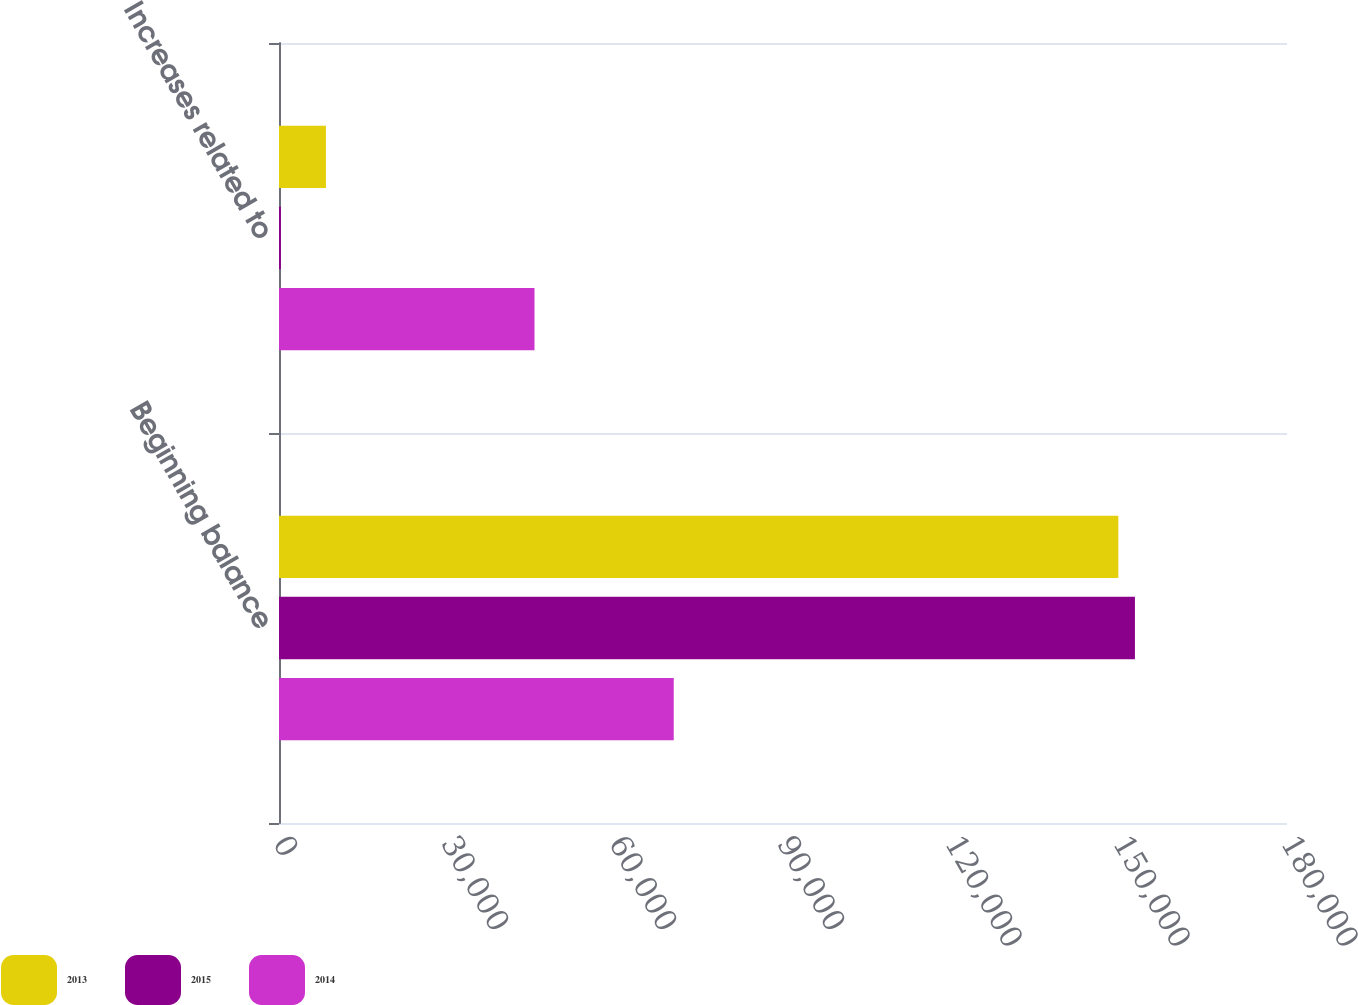<chart> <loc_0><loc_0><loc_500><loc_500><stacked_bar_chart><ecel><fcel>Beginning balance<fcel>Increases related to<nl><fcel>2013<fcel>149878<fcel>8381<nl><fcel>2015<fcel>152845<fcel>341<nl><fcel>2014<fcel>70490<fcel>45624<nl></chart> 